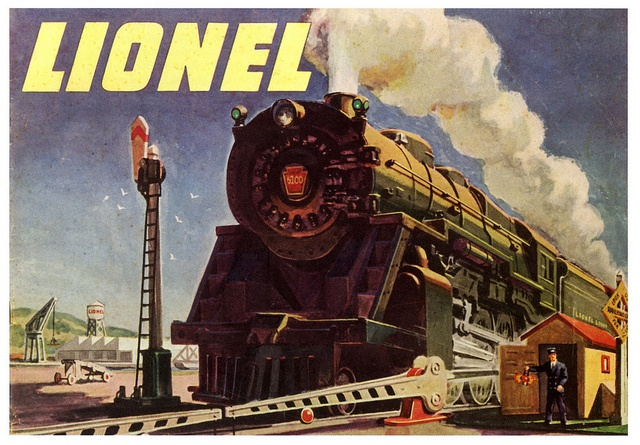Describe the objects in this image and their specific colors. I can see train in white, black, maroon, olive, and tan tones and people in white, black, maroon, gray, and tan tones in this image. 